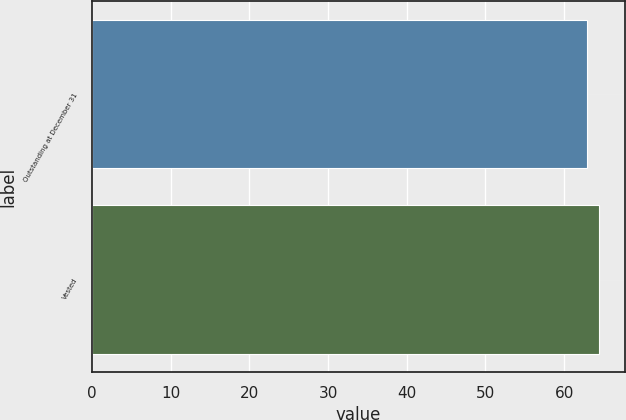Convert chart. <chart><loc_0><loc_0><loc_500><loc_500><bar_chart><fcel>Outstanding at December 31<fcel>Vested<nl><fcel>62.91<fcel>64.47<nl></chart> 